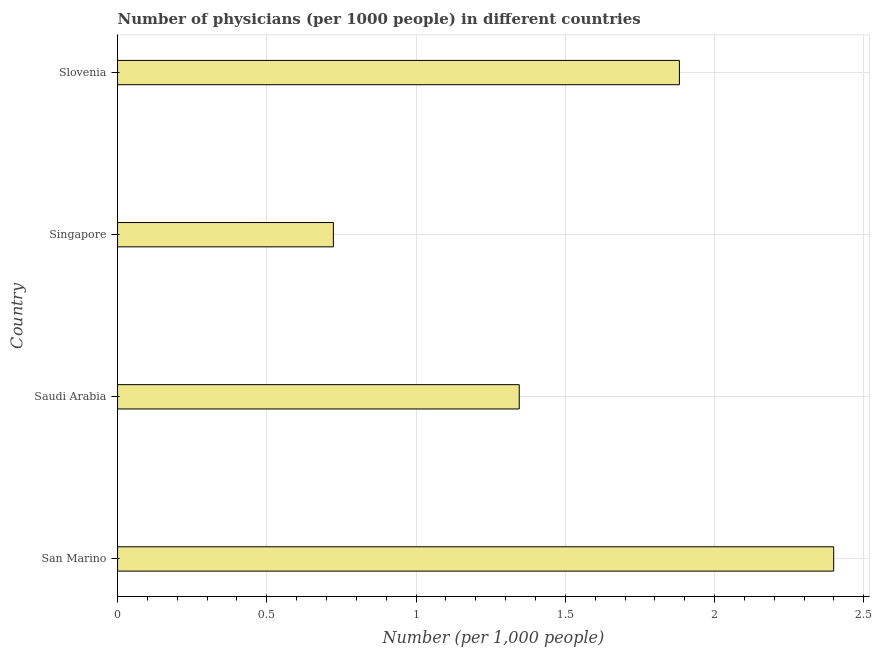What is the title of the graph?
Your response must be concise. Number of physicians (per 1000 people) in different countries. What is the label or title of the X-axis?
Offer a very short reply. Number (per 1,0 people). What is the number of physicians in Singapore?
Your answer should be very brief. 0.72. Across all countries, what is the maximum number of physicians?
Give a very brief answer. 2.4. Across all countries, what is the minimum number of physicians?
Give a very brief answer. 0.72. In which country was the number of physicians maximum?
Your answer should be compact. San Marino. In which country was the number of physicians minimum?
Provide a succinct answer. Singapore. What is the sum of the number of physicians?
Your answer should be compact. 6.35. What is the difference between the number of physicians in San Marino and Singapore?
Your response must be concise. 1.68. What is the average number of physicians per country?
Your answer should be very brief. 1.59. What is the median number of physicians?
Give a very brief answer. 1.61. What is the ratio of the number of physicians in San Marino to that in Saudi Arabia?
Your answer should be compact. 1.78. What is the difference between the highest and the second highest number of physicians?
Keep it short and to the point. 0.52. What is the difference between the highest and the lowest number of physicians?
Your answer should be compact. 1.68. In how many countries, is the number of physicians greater than the average number of physicians taken over all countries?
Ensure brevity in your answer.  2. Are all the bars in the graph horizontal?
Offer a terse response. Yes. What is the difference between two consecutive major ticks on the X-axis?
Your answer should be compact. 0.5. What is the Number (per 1,000 people) of San Marino?
Your answer should be very brief. 2.4. What is the Number (per 1,000 people) of Saudi Arabia?
Your answer should be very brief. 1.35. What is the Number (per 1,000 people) in Singapore?
Your answer should be compact. 0.72. What is the Number (per 1,000 people) in Slovenia?
Your answer should be very brief. 1.88. What is the difference between the Number (per 1,000 people) in San Marino and Saudi Arabia?
Provide a succinct answer. 1.05. What is the difference between the Number (per 1,000 people) in San Marino and Singapore?
Your response must be concise. 1.68. What is the difference between the Number (per 1,000 people) in San Marino and Slovenia?
Your answer should be very brief. 0.52. What is the difference between the Number (per 1,000 people) in Saudi Arabia and Singapore?
Give a very brief answer. 0.62. What is the difference between the Number (per 1,000 people) in Saudi Arabia and Slovenia?
Ensure brevity in your answer.  -0.54. What is the difference between the Number (per 1,000 people) in Singapore and Slovenia?
Make the answer very short. -1.16. What is the ratio of the Number (per 1,000 people) in San Marino to that in Saudi Arabia?
Your answer should be very brief. 1.78. What is the ratio of the Number (per 1,000 people) in San Marino to that in Singapore?
Your answer should be compact. 3.32. What is the ratio of the Number (per 1,000 people) in San Marino to that in Slovenia?
Your answer should be compact. 1.27. What is the ratio of the Number (per 1,000 people) in Saudi Arabia to that in Singapore?
Provide a short and direct response. 1.86. What is the ratio of the Number (per 1,000 people) in Saudi Arabia to that in Slovenia?
Your response must be concise. 0.71. What is the ratio of the Number (per 1,000 people) in Singapore to that in Slovenia?
Make the answer very short. 0.38. 